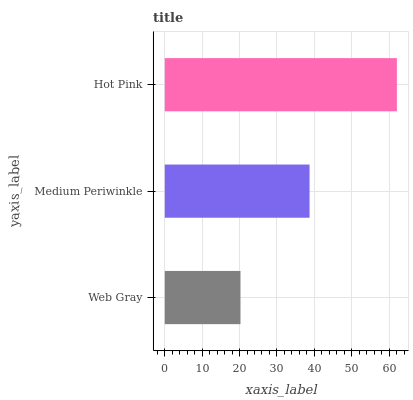Is Web Gray the minimum?
Answer yes or no. Yes. Is Hot Pink the maximum?
Answer yes or no. Yes. Is Medium Periwinkle the minimum?
Answer yes or no. No. Is Medium Periwinkle the maximum?
Answer yes or no. No. Is Medium Periwinkle greater than Web Gray?
Answer yes or no. Yes. Is Web Gray less than Medium Periwinkle?
Answer yes or no. Yes. Is Web Gray greater than Medium Periwinkle?
Answer yes or no. No. Is Medium Periwinkle less than Web Gray?
Answer yes or no. No. Is Medium Periwinkle the high median?
Answer yes or no. Yes. Is Medium Periwinkle the low median?
Answer yes or no. Yes. Is Hot Pink the high median?
Answer yes or no. No. Is Web Gray the low median?
Answer yes or no. No. 